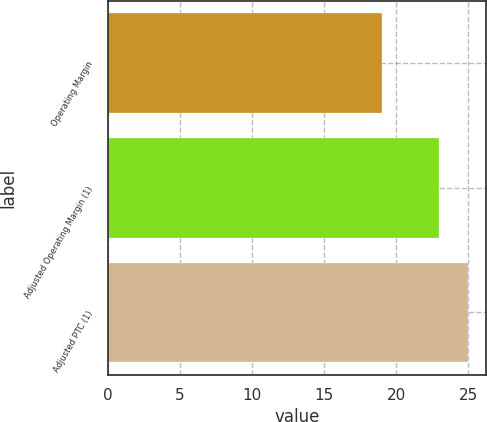Convert chart to OTSL. <chart><loc_0><loc_0><loc_500><loc_500><bar_chart><fcel>Operating Margin<fcel>Adjusted Operating Margin (1)<fcel>Adjusted PTC (1)<nl><fcel>19<fcel>23<fcel>25<nl></chart> 